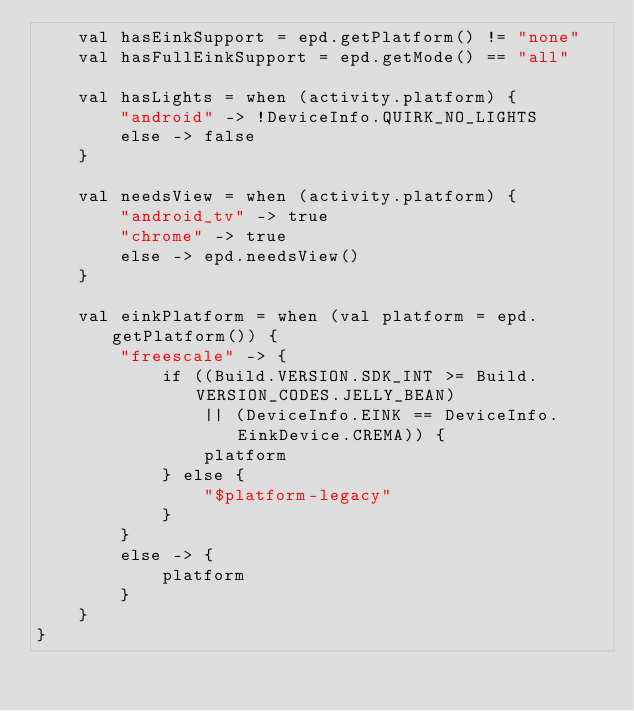Convert code to text. <code><loc_0><loc_0><loc_500><loc_500><_Kotlin_>    val hasEinkSupport = epd.getPlatform() != "none"
    val hasFullEinkSupport = epd.getMode() == "all"

    val hasLights = when (activity.platform) {
        "android" -> !DeviceInfo.QUIRK_NO_LIGHTS
        else -> false
    }

    val needsView = when (activity.platform) {
        "android_tv" -> true
        "chrome" -> true
        else -> epd.needsView()
    }

    val einkPlatform = when (val platform = epd.getPlatform()) {
        "freescale" -> {
            if ((Build.VERSION.SDK_INT >= Build.VERSION_CODES.JELLY_BEAN)
                || (DeviceInfo.EINK == DeviceInfo.EinkDevice.CREMA)) {
                platform
            } else {
                "$platform-legacy"
            }
        }
        else -> {
            platform
        }
    }
}
</code> 